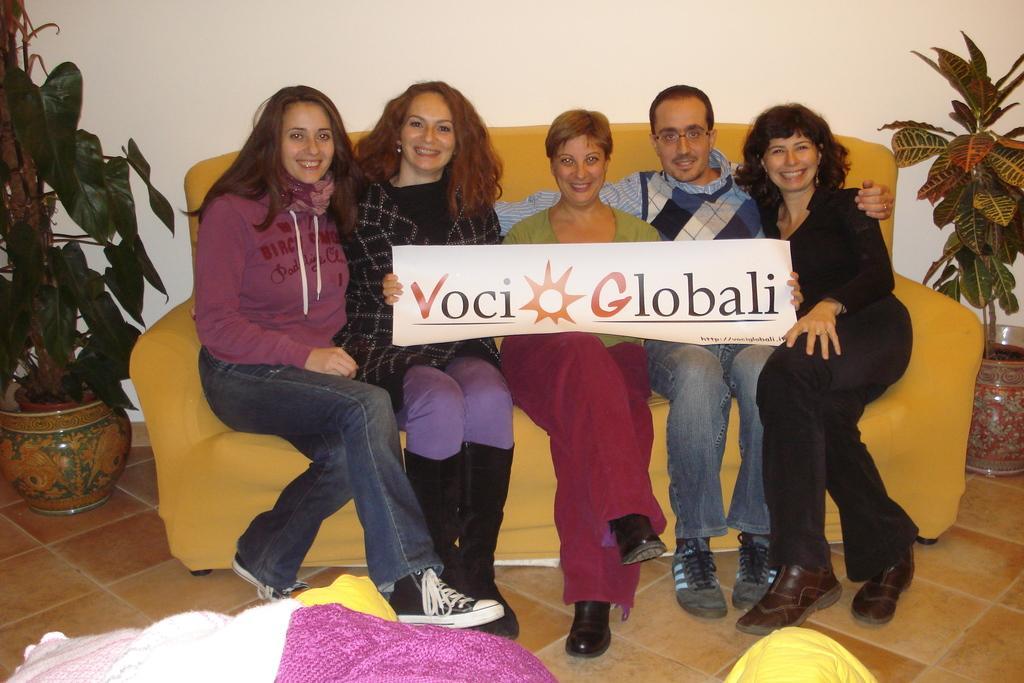Please provide a concise description of this image. In the center of the image we can see some people are sitting on a couch and smiling and a lady a holding a board. In the background of the image we can see the wall, plants, pots. At the bottom of the image we can see the roof and clothes. 